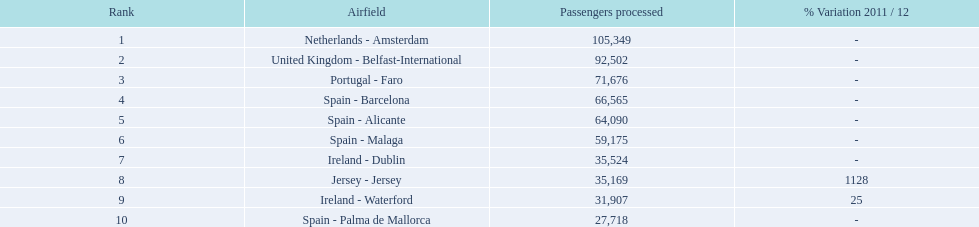How many passengers did the united kingdom handle? 92,502. Parse the full table. {'header': ['Rank', 'Airfield', 'Passengers processed', '% Variation 2011 / 12'], 'rows': [['1', 'Netherlands - Amsterdam', '105,349', '-'], ['2', 'United Kingdom - Belfast-International', '92,502', '-'], ['3', 'Portugal - Faro', '71,676', '-'], ['4', 'Spain - Barcelona', '66,565', '-'], ['5', 'Spain - Alicante', '64,090', '-'], ['6', 'Spain - Malaga', '59,175', '-'], ['7', 'Ireland - Dublin', '35,524', '-'], ['8', 'Jersey - Jersey', '35,169', '1128'], ['9', 'Ireland - Waterford', '31,907', '25'], ['10', 'Spain - Palma de Mallorca', '27,718', '-']]} Who handled more passengers than this? Netherlands - Amsterdam. 